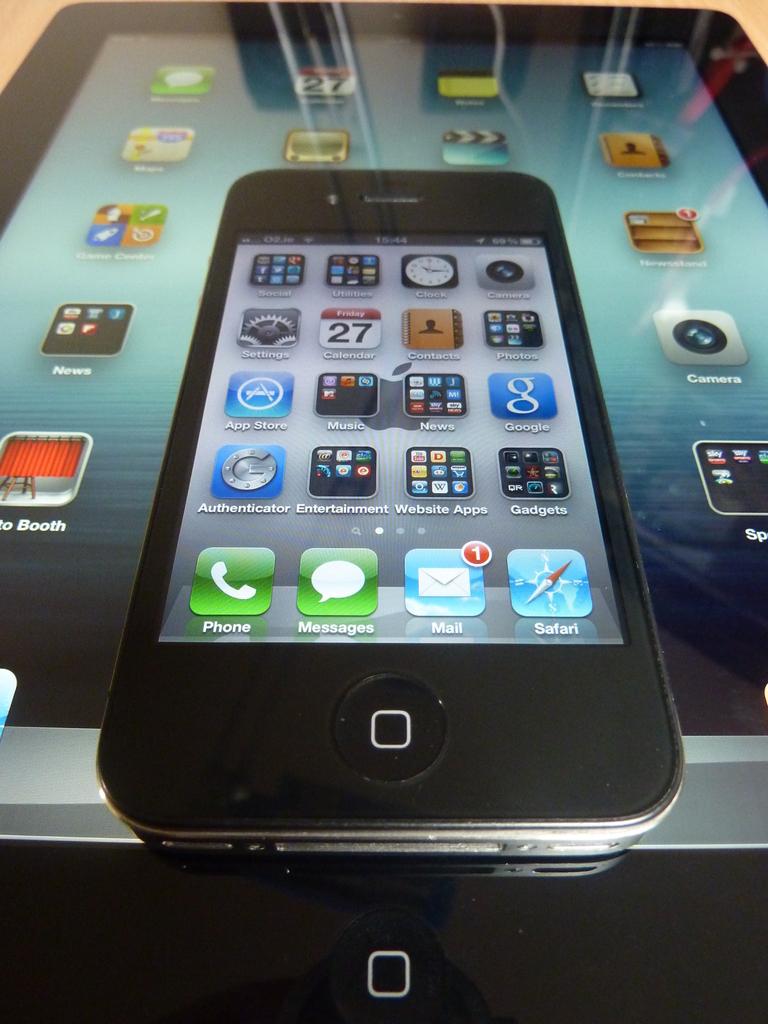How many pieces of mail are on the phone?
Offer a very short reply. 1. What app is on the bottom right?
Your answer should be very brief. Safari. 